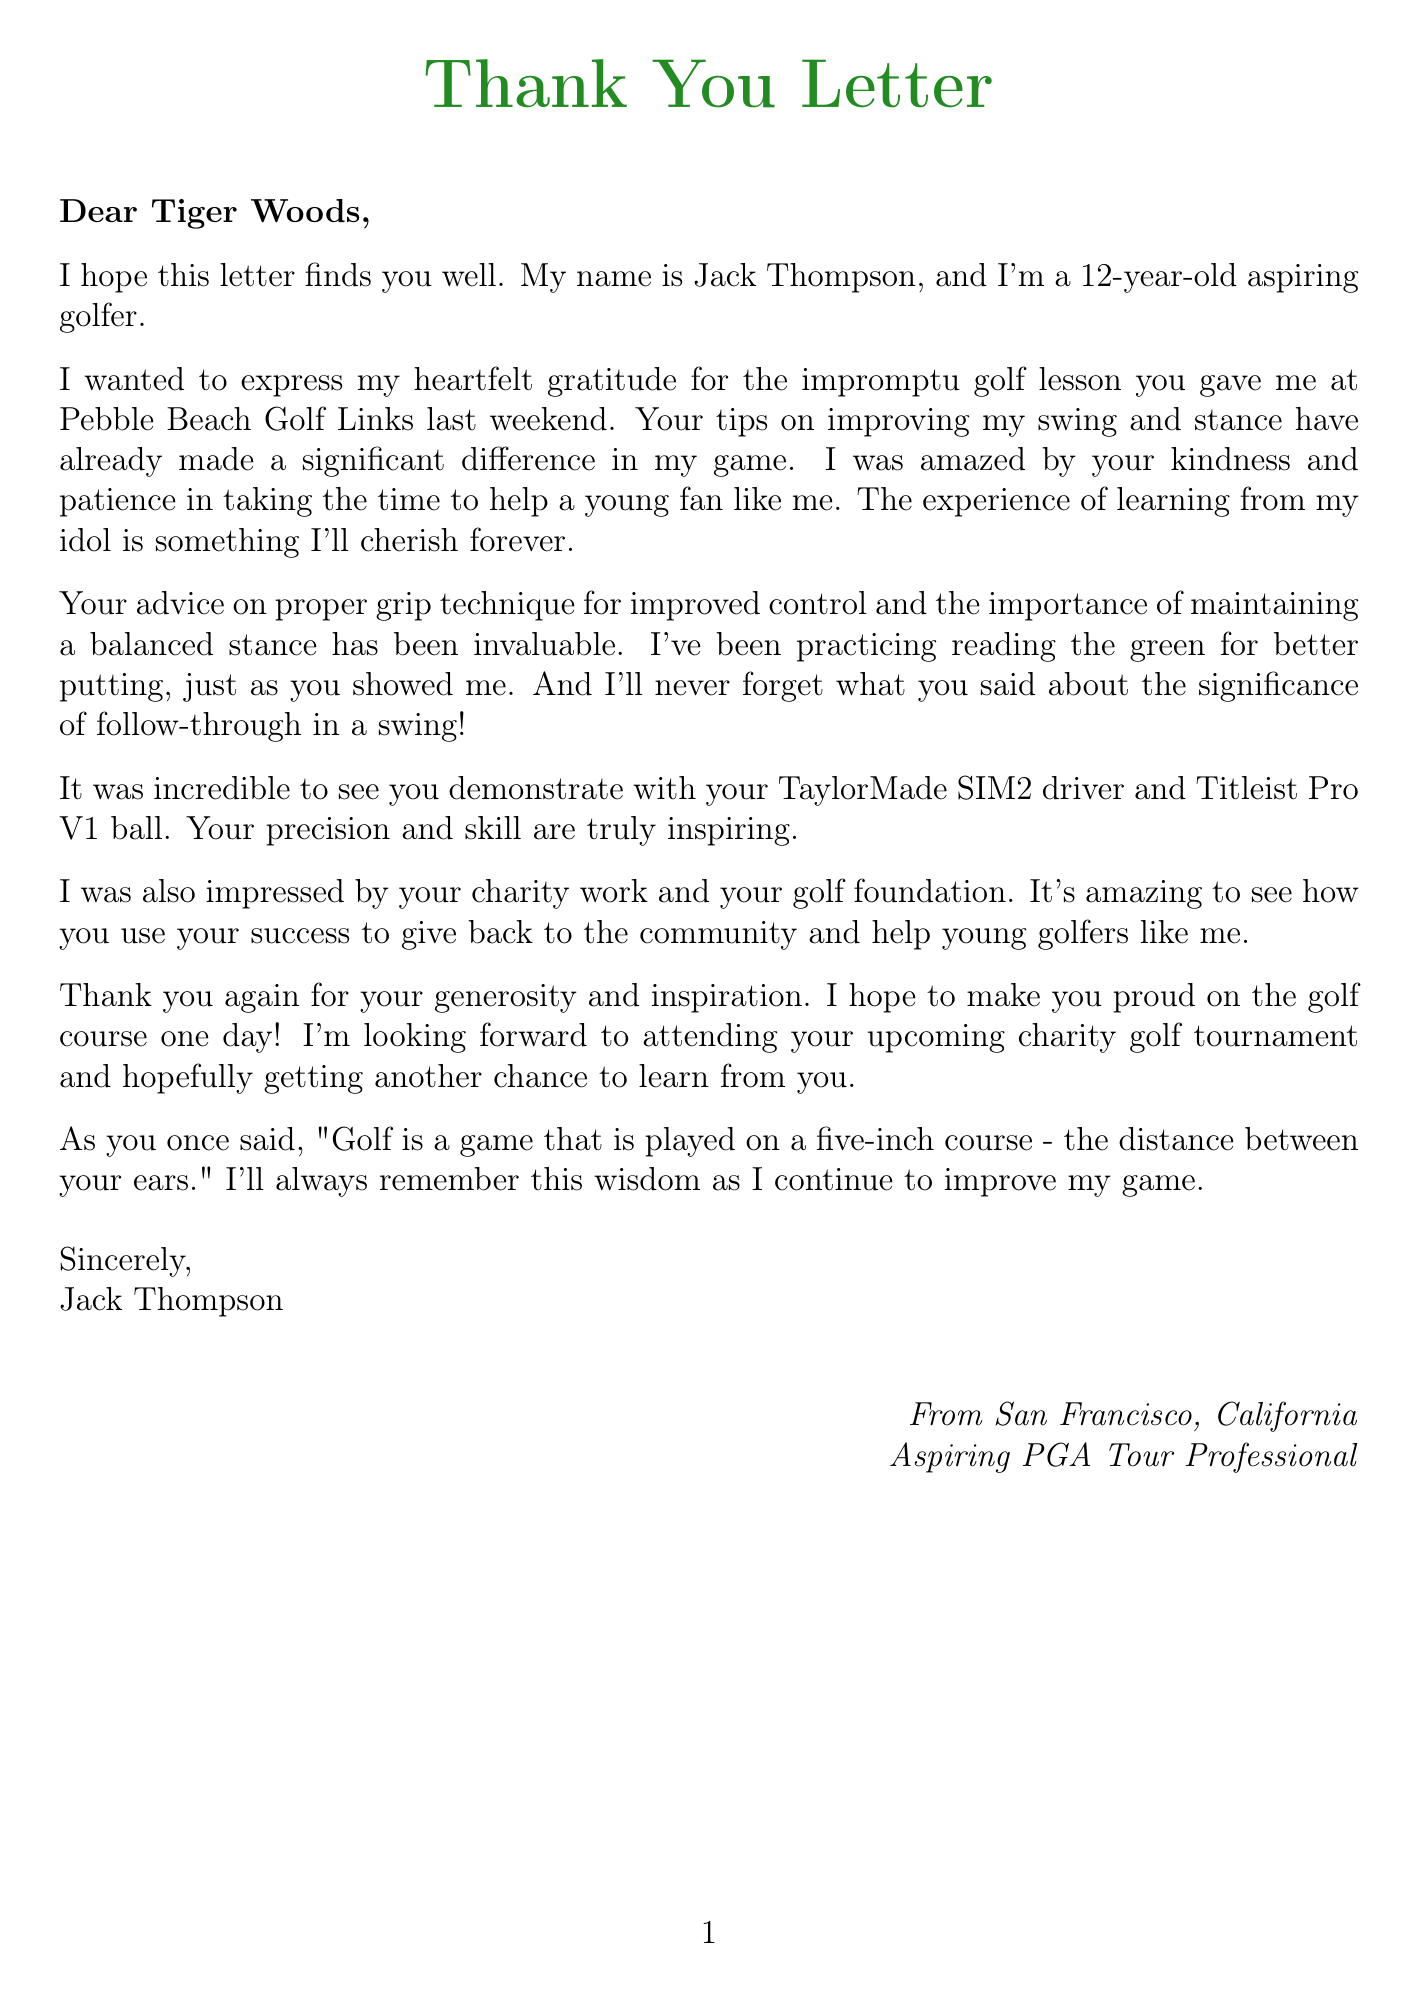What is the name of the young fan? The letter states that the young fan's name is Jack Thompson.
Answer: Jack Thompson Where did the golfing lesson take place? The letter mentions that the lesson took place at Pebble Beach Golf Links.
Answer: Pebble Beach Golf Links What age is the fan? The letter indicates the age of the fan, Jack Thompson, is 12 years old.
Answer: 12 What type of driver was demonstrated during the lesson? The letter notes that the driver used was a TaylorMade SIM2 driver.
Answer: TaylorMade SIM2 driver What is the famous quote mentioned in the letter? The letter includes the quote "Golf is a game that is played on a five-inch course - the distance between your ears."
Answer: "Golf is a game that is played on a five-inch course - the distance between your ears." What is the young fan's aspiration? The letter states that Jack Thompson aspires to become a professional golfer and play on the PGA Tour.
Answer: To become a professional golfer and play on the PGA Tour What significant achievement is Tiger Woods known for? The letter identifies that Tiger Woods is known for being a 15-time major golf champion.
Answer: 15-time major golf champion What is the purpose of Jack Thompson's letter? The purpose of the letter is to express gratitude for the golf lesson and the inspiration received.
Answer: To express gratitude 